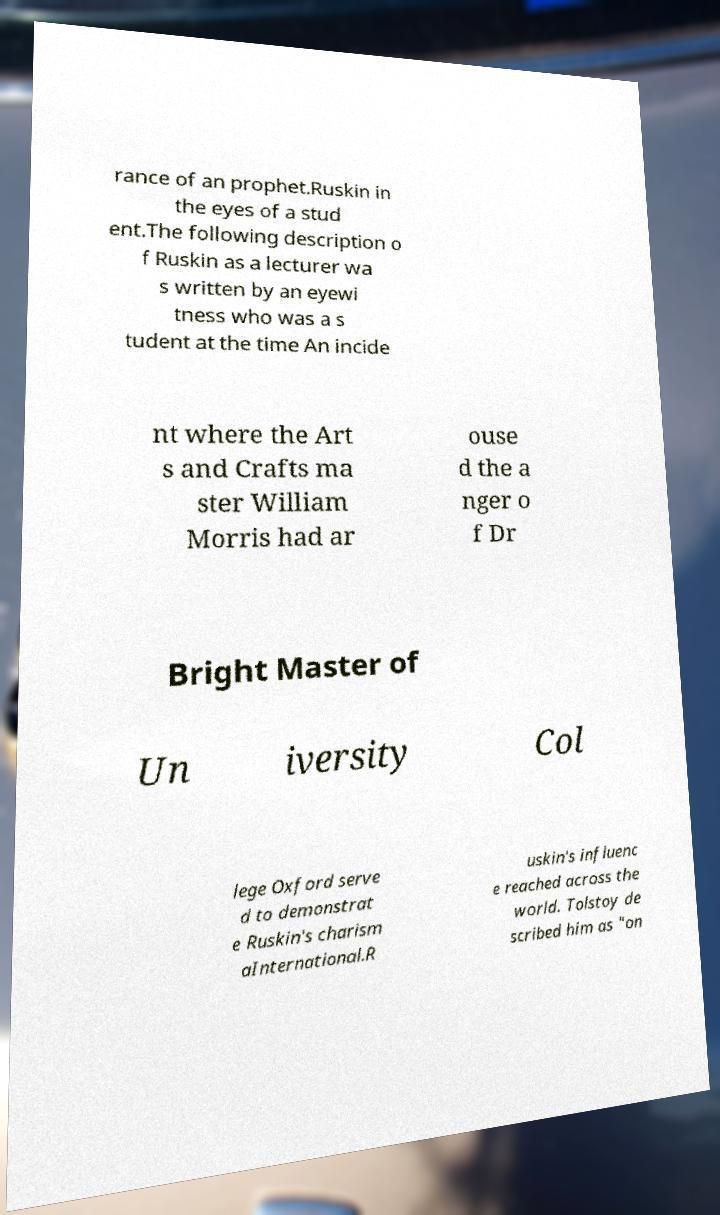For documentation purposes, I need the text within this image transcribed. Could you provide that? rance of an prophet.Ruskin in the eyes of a stud ent.The following description o f Ruskin as a lecturer wa s written by an eyewi tness who was a s tudent at the time An incide nt where the Art s and Crafts ma ster William Morris had ar ouse d the a nger o f Dr Bright Master of Un iversity Col lege Oxford serve d to demonstrat e Ruskin's charism aInternational.R uskin's influenc e reached across the world. Tolstoy de scribed him as "on 